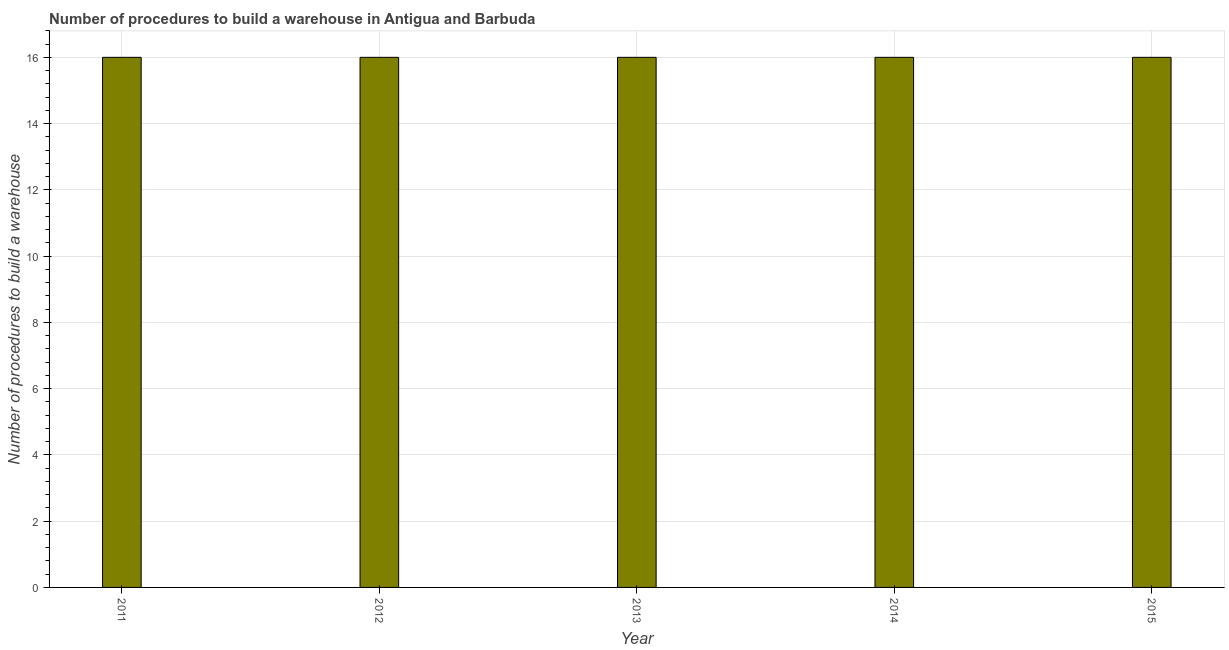Does the graph contain any zero values?
Offer a terse response. No. Does the graph contain grids?
Your response must be concise. Yes. What is the title of the graph?
Give a very brief answer. Number of procedures to build a warehouse in Antigua and Barbuda. What is the label or title of the Y-axis?
Your answer should be compact. Number of procedures to build a warehouse. Across all years, what is the maximum number of procedures to build a warehouse?
Your answer should be very brief. 16. What is the average number of procedures to build a warehouse per year?
Offer a terse response. 16. What is the median number of procedures to build a warehouse?
Your response must be concise. 16. In how many years, is the number of procedures to build a warehouse greater than 0.4 ?
Ensure brevity in your answer.  5. Do a majority of the years between 2011 and 2013 (inclusive) have number of procedures to build a warehouse greater than 4.4 ?
Your answer should be very brief. Yes. Is the number of procedures to build a warehouse in 2013 less than that in 2015?
Your response must be concise. No. Is the difference between the number of procedures to build a warehouse in 2011 and 2012 greater than the difference between any two years?
Offer a terse response. Yes. What is the difference between the highest and the lowest number of procedures to build a warehouse?
Your answer should be compact. 0. What is the difference between two consecutive major ticks on the Y-axis?
Provide a short and direct response. 2. Are the values on the major ticks of Y-axis written in scientific E-notation?
Offer a terse response. No. What is the Number of procedures to build a warehouse in 2013?
Offer a terse response. 16. What is the Number of procedures to build a warehouse of 2015?
Offer a very short reply. 16. What is the difference between the Number of procedures to build a warehouse in 2011 and 2013?
Your response must be concise. 0. What is the difference between the Number of procedures to build a warehouse in 2012 and 2014?
Ensure brevity in your answer.  0. What is the difference between the Number of procedures to build a warehouse in 2013 and 2014?
Give a very brief answer. 0. What is the difference between the Number of procedures to build a warehouse in 2013 and 2015?
Provide a succinct answer. 0. What is the difference between the Number of procedures to build a warehouse in 2014 and 2015?
Ensure brevity in your answer.  0. What is the ratio of the Number of procedures to build a warehouse in 2011 to that in 2012?
Provide a succinct answer. 1. What is the ratio of the Number of procedures to build a warehouse in 2012 to that in 2013?
Offer a terse response. 1. What is the ratio of the Number of procedures to build a warehouse in 2012 to that in 2014?
Provide a succinct answer. 1. What is the ratio of the Number of procedures to build a warehouse in 2014 to that in 2015?
Offer a very short reply. 1. 